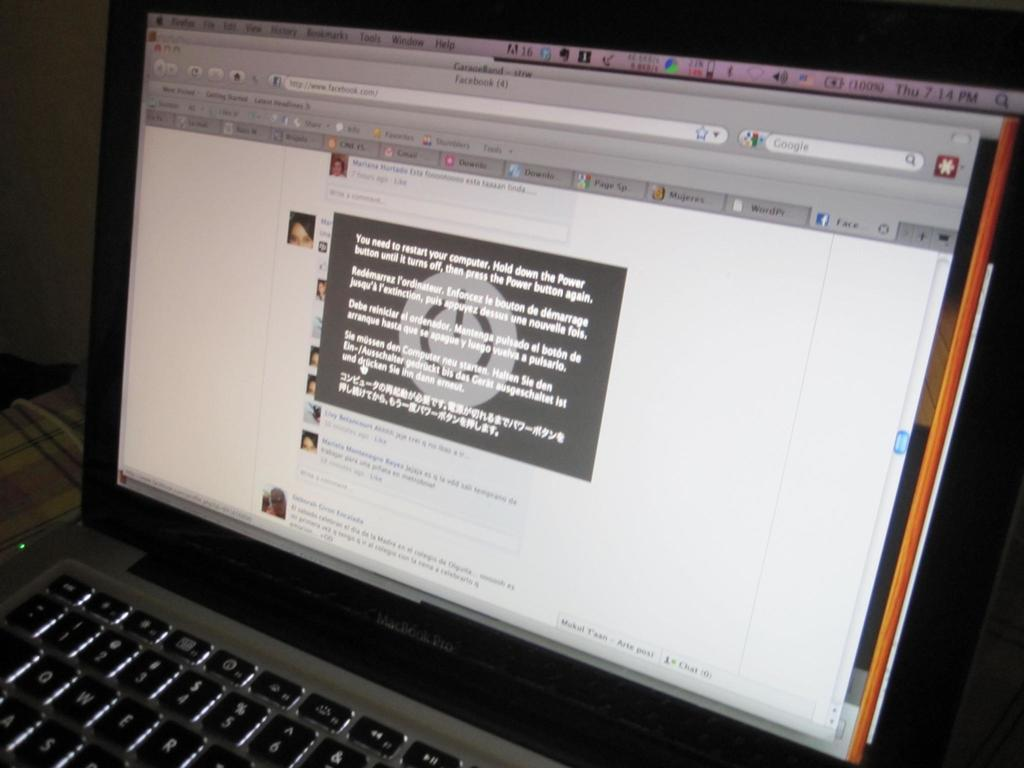Provide a one-sentence caption for the provided image. A laptop with a popup in Spanish around the time of 7:14 pm. 